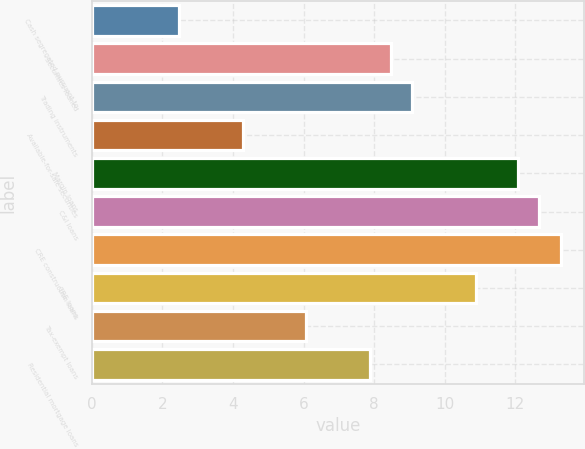Convert chart. <chart><loc_0><loc_0><loc_500><loc_500><bar_chart><fcel>Cash segregated pursuant to<fcel>Securities loaned<fcel>Trading instruments<fcel>Available-for-sale securities<fcel>Margin loans<fcel>C&I loans<fcel>CRE construction loans<fcel>CRE loans<fcel>Tax-exempt loans<fcel>Residential mortgage loans<nl><fcel>2.48<fcel>8.48<fcel>9.08<fcel>4.28<fcel>12.08<fcel>12.68<fcel>13.28<fcel>10.88<fcel>6.08<fcel>7.88<nl></chart> 